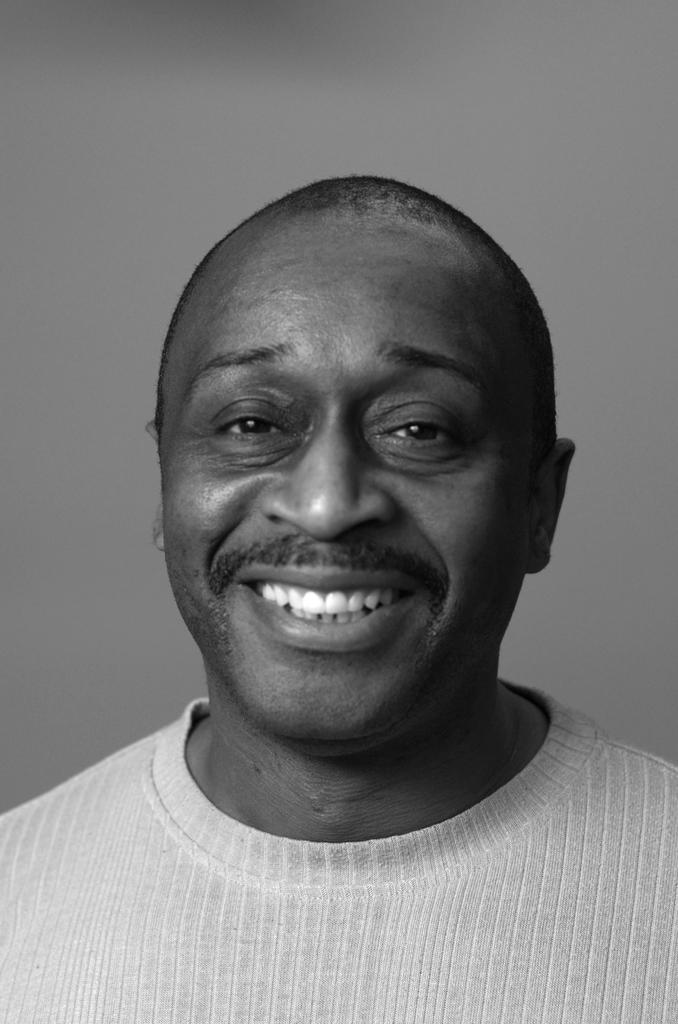Who or what is present in the image? There is a person in the image. What can be seen in the background of the image? There is a wall in the image. What type of list is the person holding in the image? There is no list present in the image; only a person and a wall are visible. 